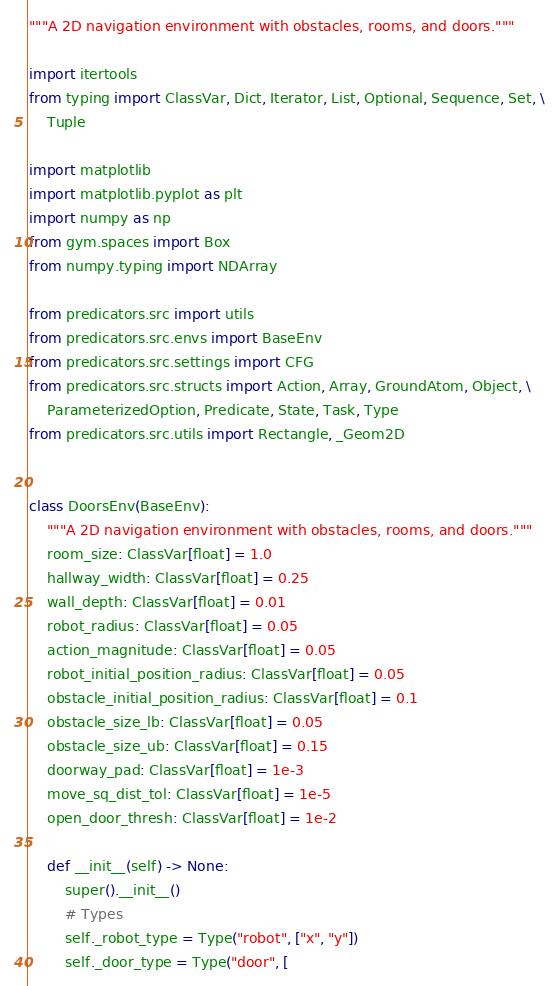<code> <loc_0><loc_0><loc_500><loc_500><_Python_>"""A 2D navigation environment with obstacles, rooms, and doors."""

import itertools
from typing import ClassVar, Dict, Iterator, List, Optional, Sequence, Set, \
    Tuple

import matplotlib
import matplotlib.pyplot as plt
import numpy as np
from gym.spaces import Box
from numpy.typing import NDArray

from predicators.src import utils
from predicators.src.envs import BaseEnv
from predicators.src.settings import CFG
from predicators.src.structs import Action, Array, GroundAtom, Object, \
    ParameterizedOption, Predicate, State, Task, Type
from predicators.src.utils import Rectangle, _Geom2D


class DoorsEnv(BaseEnv):
    """A 2D navigation environment with obstacles, rooms, and doors."""
    room_size: ClassVar[float] = 1.0
    hallway_width: ClassVar[float] = 0.25
    wall_depth: ClassVar[float] = 0.01
    robot_radius: ClassVar[float] = 0.05
    action_magnitude: ClassVar[float] = 0.05
    robot_initial_position_radius: ClassVar[float] = 0.05
    obstacle_initial_position_radius: ClassVar[float] = 0.1
    obstacle_size_lb: ClassVar[float] = 0.05
    obstacle_size_ub: ClassVar[float] = 0.15
    doorway_pad: ClassVar[float] = 1e-3
    move_sq_dist_tol: ClassVar[float] = 1e-5
    open_door_thresh: ClassVar[float] = 1e-2

    def __init__(self) -> None:
        super().__init__()
        # Types
        self._robot_type = Type("robot", ["x", "y"])
        self._door_type = Type("door", [</code> 